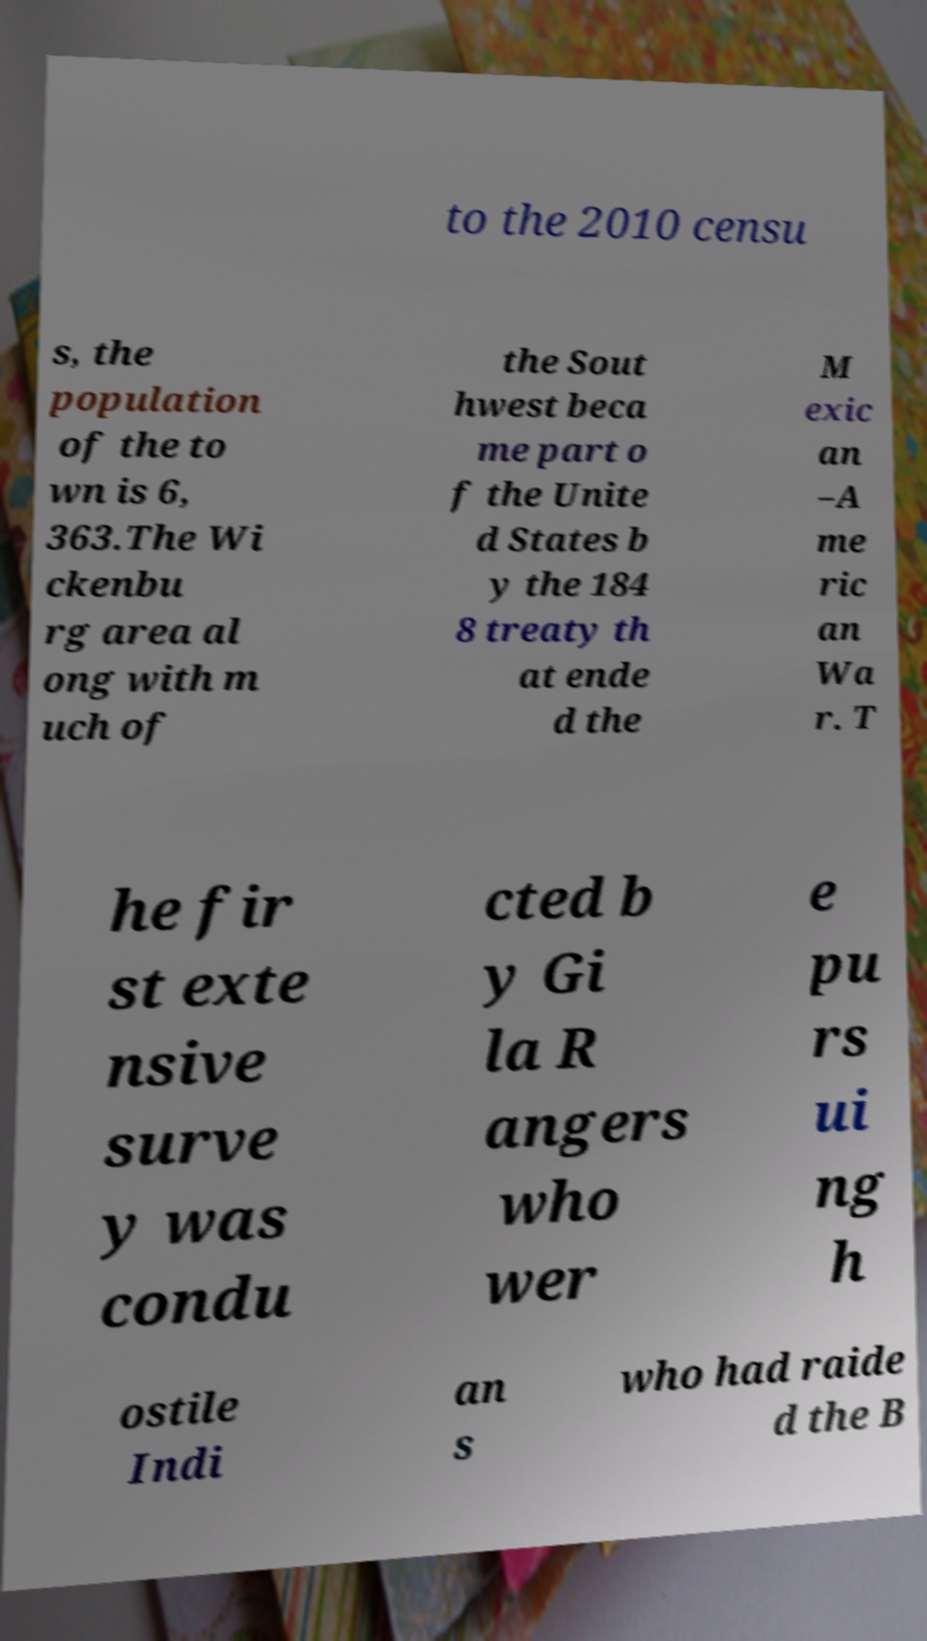For documentation purposes, I need the text within this image transcribed. Could you provide that? to the 2010 censu s, the population of the to wn is 6, 363.The Wi ckenbu rg area al ong with m uch of the Sout hwest beca me part o f the Unite d States b y the 184 8 treaty th at ende d the M exic an –A me ric an Wa r. T he fir st exte nsive surve y was condu cted b y Gi la R angers who wer e pu rs ui ng h ostile Indi an s who had raide d the B 